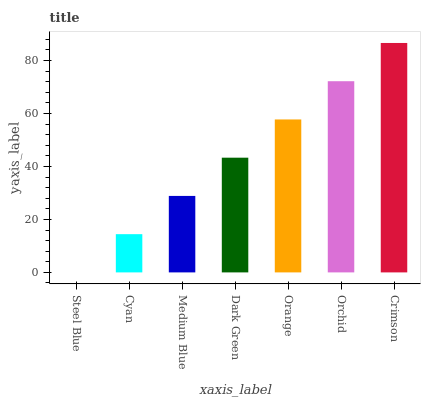Is Steel Blue the minimum?
Answer yes or no. Yes. Is Crimson the maximum?
Answer yes or no. Yes. Is Cyan the minimum?
Answer yes or no. No. Is Cyan the maximum?
Answer yes or no. No. Is Cyan greater than Steel Blue?
Answer yes or no. Yes. Is Steel Blue less than Cyan?
Answer yes or no. Yes. Is Steel Blue greater than Cyan?
Answer yes or no. No. Is Cyan less than Steel Blue?
Answer yes or no. No. Is Dark Green the high median?
Answer yes or no. Yes. Is Dark Green the low median?
Answer yes or no. Yes. Is Cyan the high median?
Answer yes or no. No. Is Steel Blue the low median?
Answer yes or no. No. 